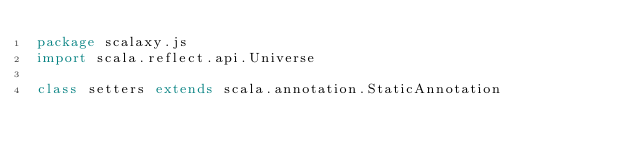<code> <loc_0><loc_0><loc_500><loc_500><_Scala_>package scalaxy.js
import scala.reflect.api.Universe

class setters extends scala.annotation.StaticAnnotation
</code> 